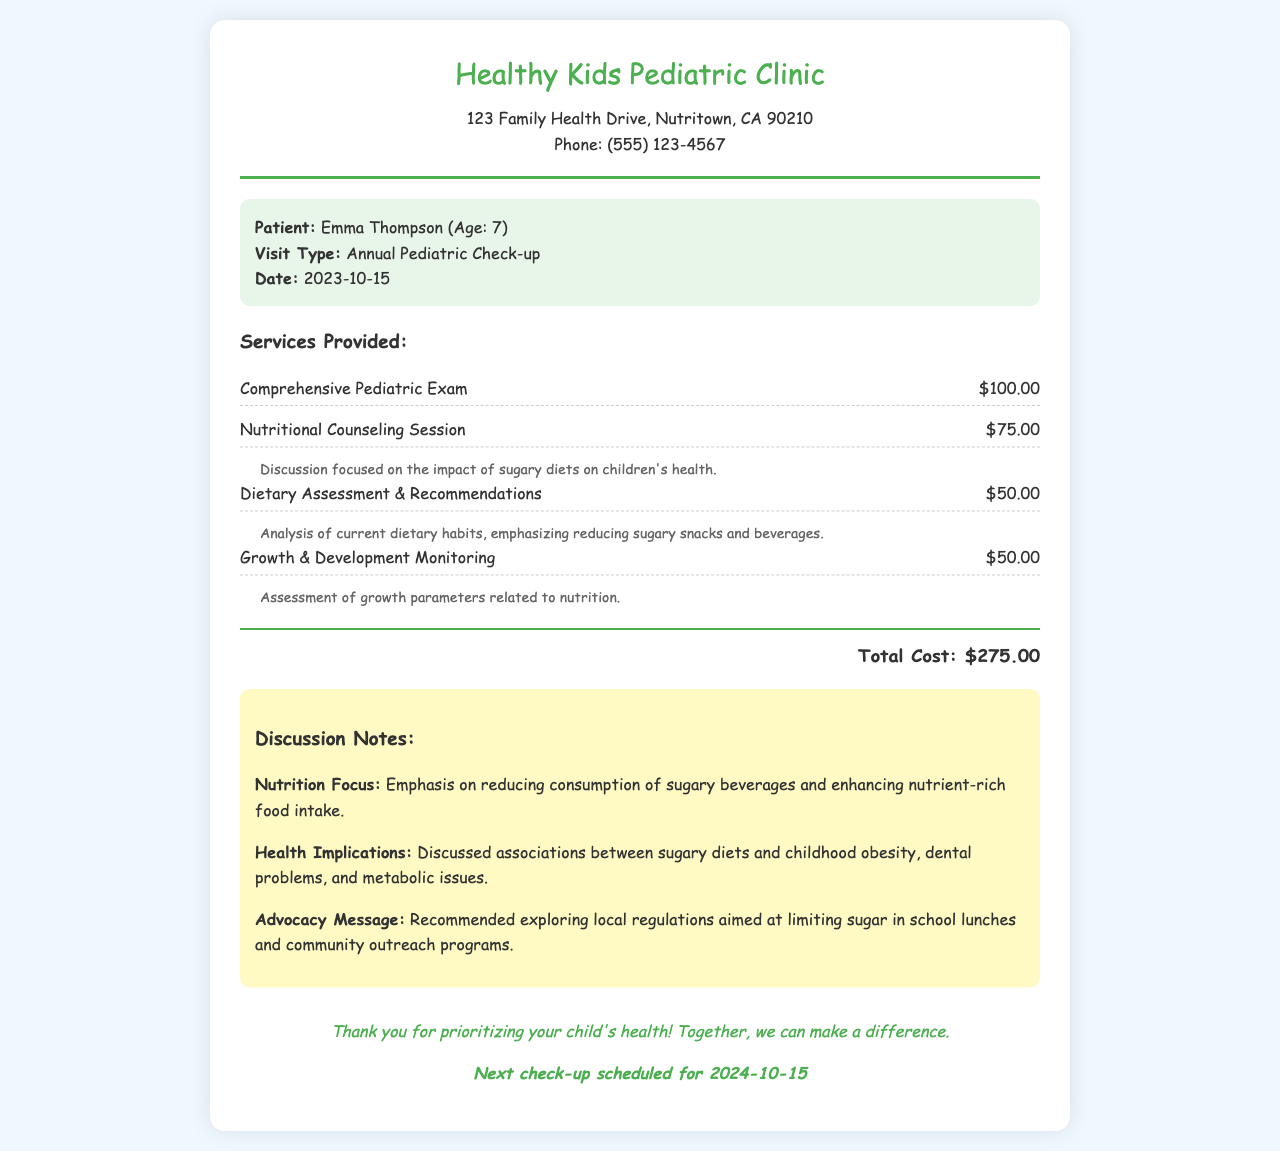What is the patient's name? The patient's name is listed at the beginning of the patient information section.
Answer: Emma Thompson What was the date of the check-up? The date of the visit is indicated in the patient information section.
Answer: 2023-10-15 How much was the Nutritional Counseling Session? The cost for this session is provided in the services section of the document.
Answer: $75.00 What health implication was discussed during the visit? The document mentions specific concerns in the discussion notes related to dietary habits.
Answer: Childhood obesity What is emphasized in the nutrition focus? The emphasis is stated in the discussion notes regarding the dietary recommendations.
Answer: Reducing consumption of sugary beverages What is the total cost of the services provided? The total amount is displayed prominently at the bottom of the services section.
Answer: $275.00 When is the next appointment scheduled? The date for the upcoming check-up is mentioned in the footer of the document.
Answer: 2024-10-15 What is the clinic's phone number? The contact information for the clinic includes the phone number listed at the top.
Answer: (555) 123-4567 What type of exam was conducted during the visit? The type of exam is specified in the services section.
Answer: Comprehensive Pediatric Exam 